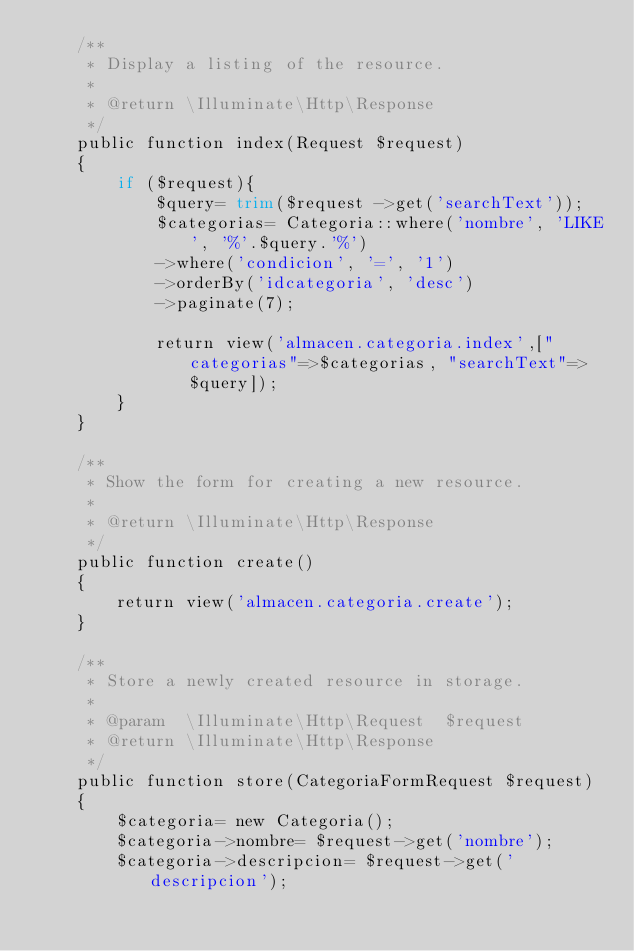<code> <loc_0><loc_0><loc_500><loc_500><_PHP_>    /**
     * Display a listing of the resource.
     *
     * @return \Illuminate\Http\Response
     */
    public function index(Request $request)
    {
        if ($request){
            $query= trim($request ->get('searchText'));
            $categorias= Categoria::where('nombre', 'LIKE', '%'.$query.'%')
            ->where('condicion', '=', '1')
            ->orderBy('idcategoria', 'desc')
            ->paginate(7);

            return view('almacen.categoria.index',["categorias"=>$categorias, "searchText"=>$query]);
        }
    }

    /**
     * Show the form for creating a new resource.
     *
     * @return \Illuminate\Http\Response
     */
    public function create()
    {
        return view('almacen.categoria.create');
    }

    /**
     * Store a newly created resource in storage.
     *
     * @param  \Illuminate\Http\Request  $request
     * @return \Illuminate\Http\Response
     */
    public function store(CategoriaFormRequest $request)
    {
        $categoria= new Categoria();
        $categoria->nombre= $request->get('nombre');
        $categoria->descripcion= $request->get('descripcion');</code> 